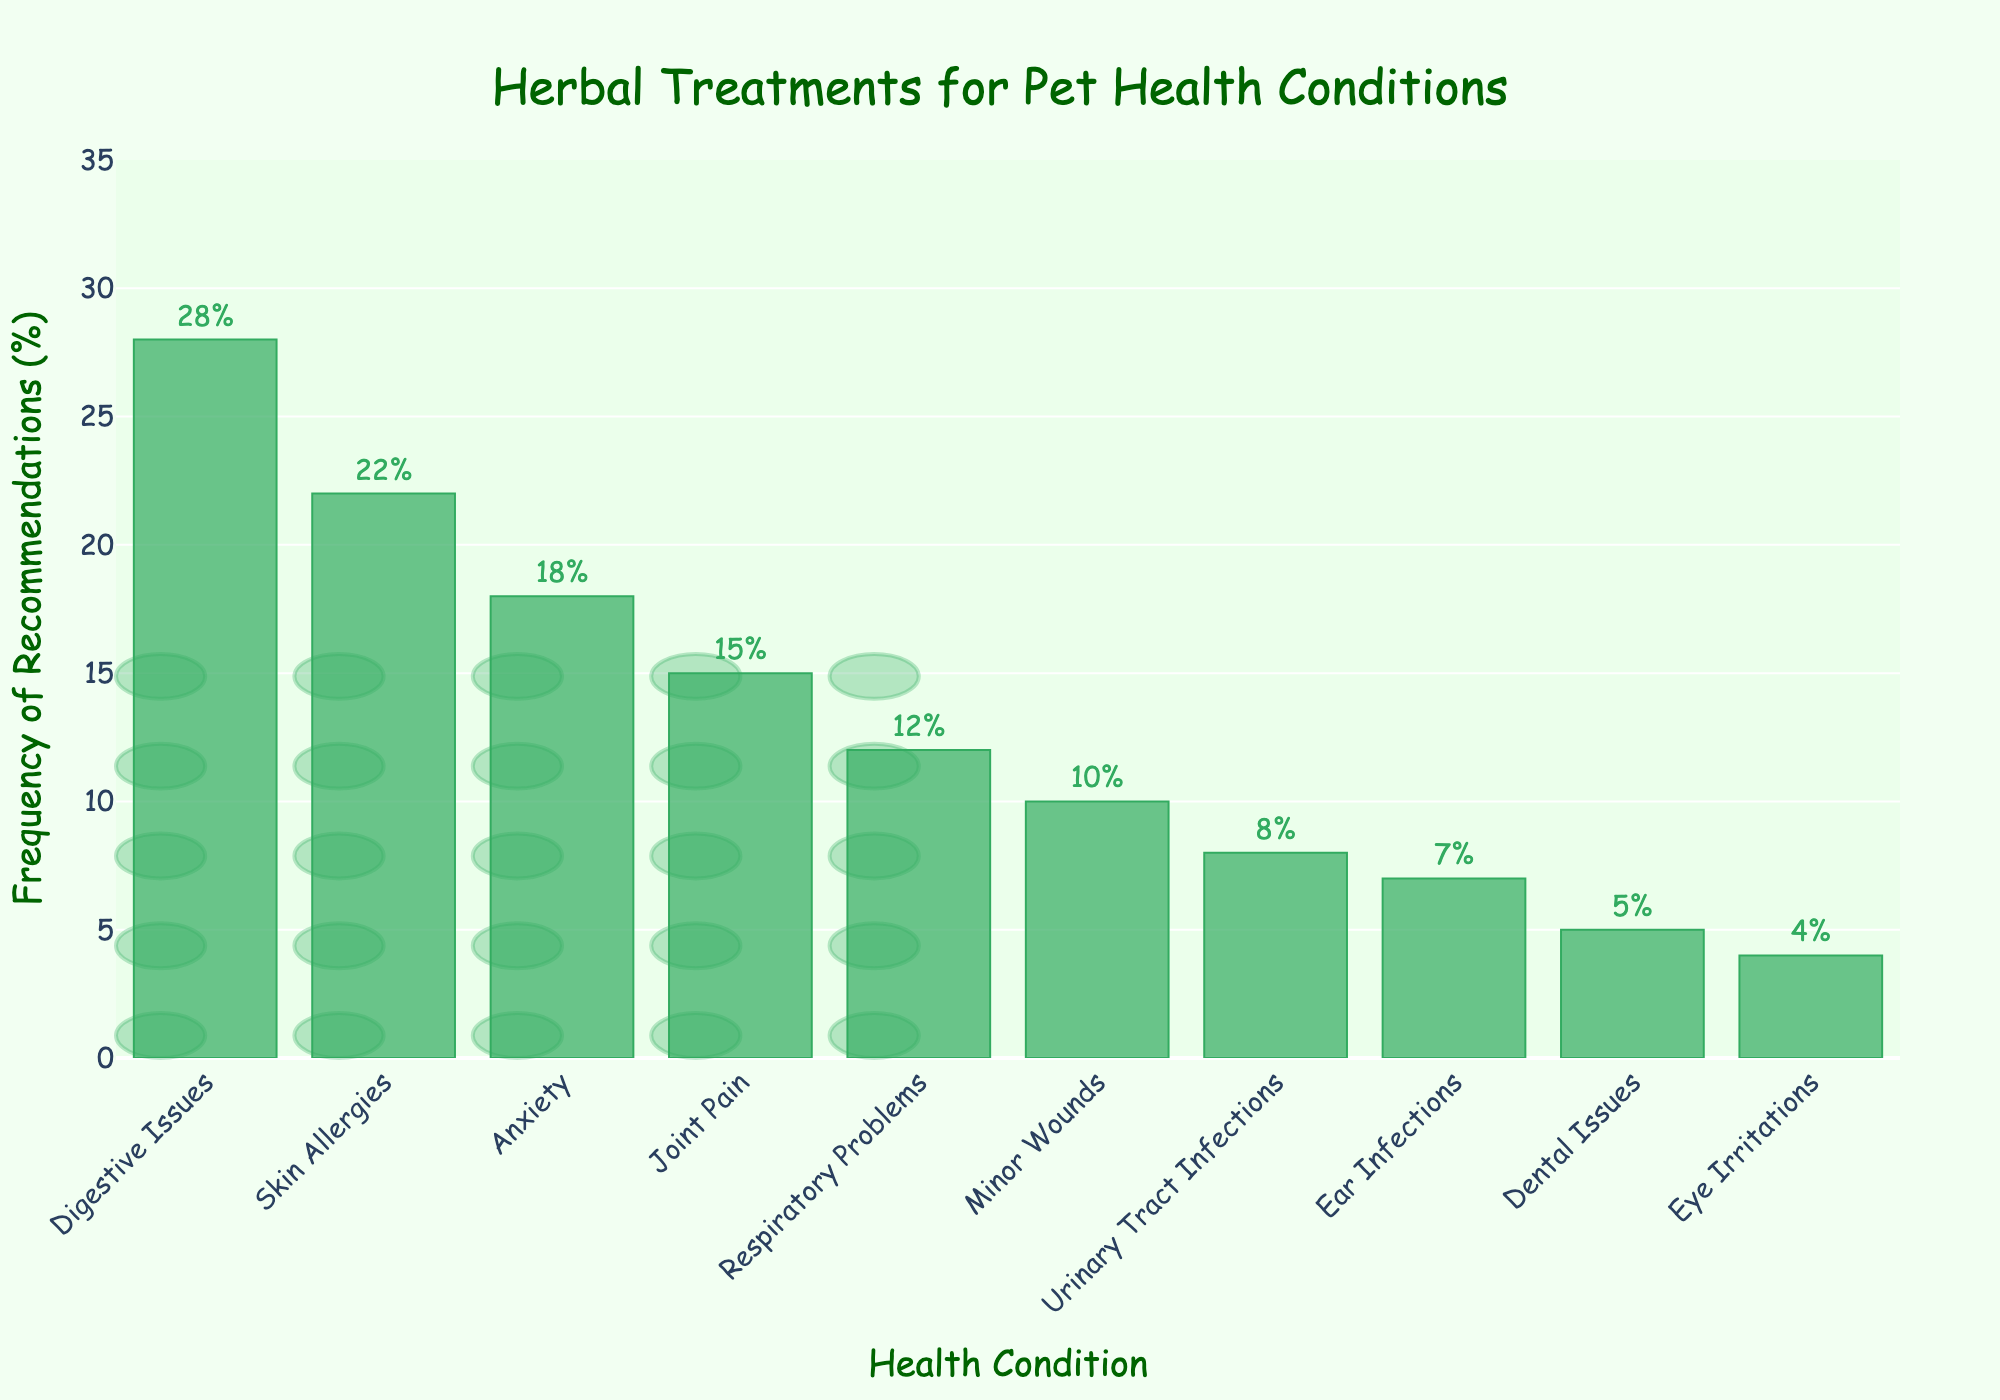What health condition has the highest frequency of herbal treatment recommendations? Digestive Issues has the highest frequency bar, indicating that it is the most recommended health condition.
Answer: Digestive Issues Which two health conditions have the lowest frequency of herbal treatment recommendations combined? Look at the two shortest bars, which represent Eye Irritations and Dental Issues. Add their frequencies: 4% (Eye Irritations) + 5% (Dental Issues) = 9%.
Answer: Eye Irritations and Dental Issues Which health condition is recommended for herbal treatment more often: Respiratory Problems or Joint Pain? Compare the heights of the bars for Respiratory Problems and Joint Pain. Respiratory Problems are at 12%, and Joint Pain is at 15%. Therefore, Joint Pain is recommended more often.
Answer: Joint Pain What's the total frequency percentage of herbal treatment recommendations for Digestive Issues, Skin Allergies, and Anxiety? Add the percentages for Digestive Issues (28%), Skin Allergies (22%), and Anxiety (18%): 28% + 22% + 18% = 68%.
Answer: 68% Are herbal treatments recommended more often for Minor Wounds or Urinary Tract Infections? Compare the heights of the bars for Minor Wounds and Urinary Tract Infections. Minor Wounds are at 10%, and Urinary Tract Infections are at 8%, so Minor Wounds are recommended more often.
Answer: Minor Wounds What is the median frequency of all health conditions listed? List all frequencies in order: 4%, 5%, 7%, 8%, 10%, 12%, 15%, 18%, 22%, 28%. With 10 data points, the median is the average of the 5th and 6th values: (10% + 12%) / 2 = 11%.
Answer: 11% How many health conditions have a frequency of herbal treatment recommendations less than 15%? Count the bars with frequencies less than 15%. There are 7 (Respiratory Problems, Minor Wounds, Urinary Tract Infections, Ear Infections, Dental Issues, Eye Irritations).
Answer: 7 Which is recommended less frequently: Anxiety or Skin Allergies? Compare the bars for Anxiety (18%) and Skin Allergies (22%). Anxiety is recommended less frequently.
Answer: Anxiety 